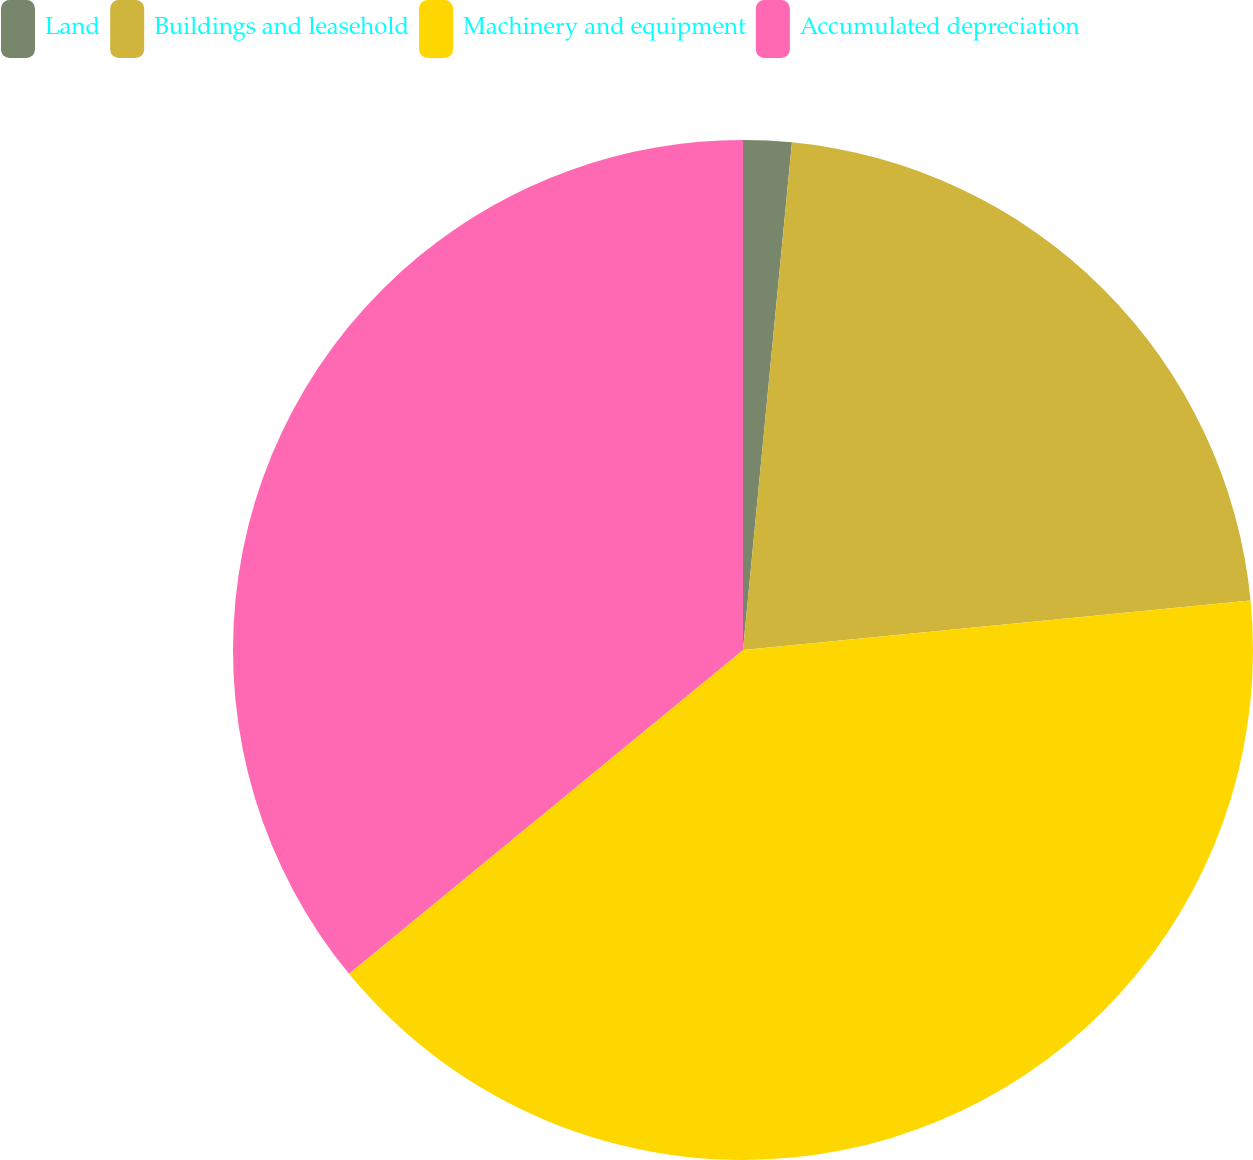Convert chart to OTSL. <chart><loc_0><loc_0><loc_500><loc_500><pie_chart><fcel>Land<fcel>Buildings and leasehold<fcel>Machinery and equipment<fcel>Accumulated depreciation<nl><fcel>1.53%<fcel>21.92%<fcel>40.6%<fcel>35.95%<nl></chart> 